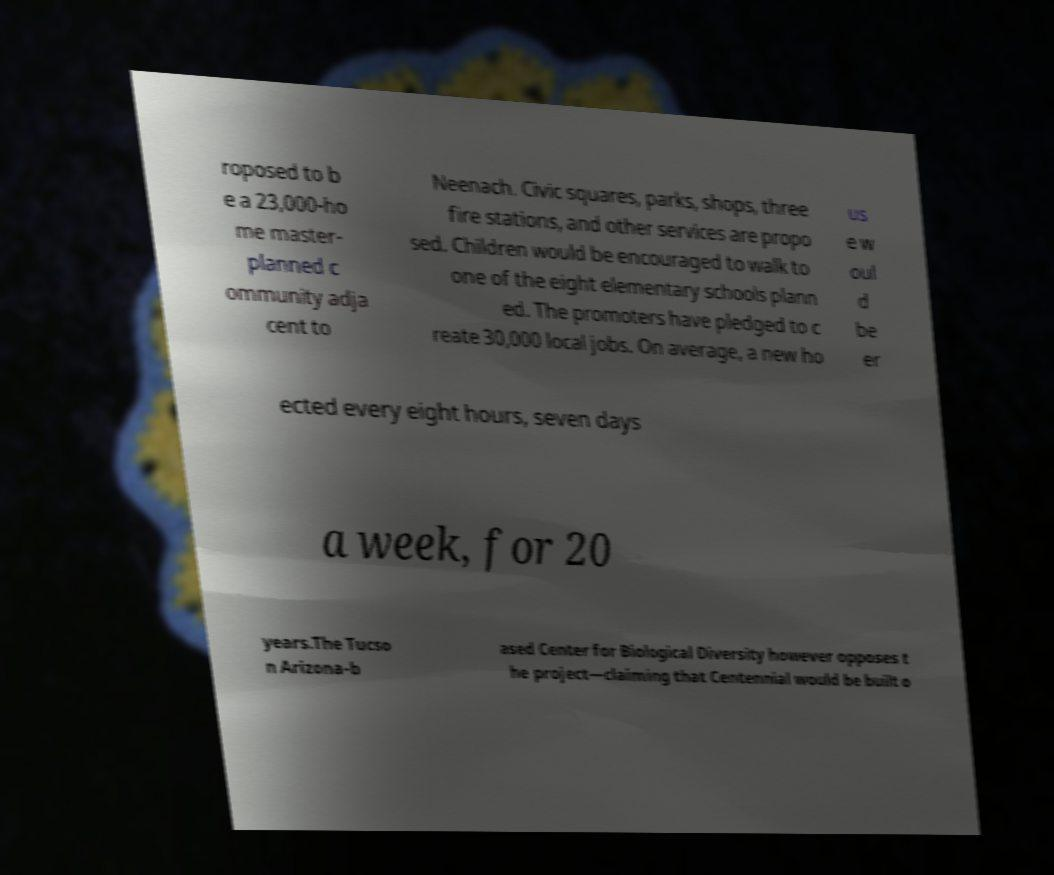I need the written content from this picture converted into text. Can you do that? roposed to b e a 23,000-ho me master- planned c ommunity adja cent to Neenach. Civic squares, parks, shops, three fire stations, and other services are propo sed. Children would be encouraged to walk to one of the eight elementary schools plann ed. The promoters have pledged to c reate 30,000 local jobs. On average, a new ho us e w oul d be er ected every eight hours, seven days a week, for 20 years.The Tucso n Arizona-b ased Center for Biological Diversity however opposes t he project—claiming that Centennial would be built o 